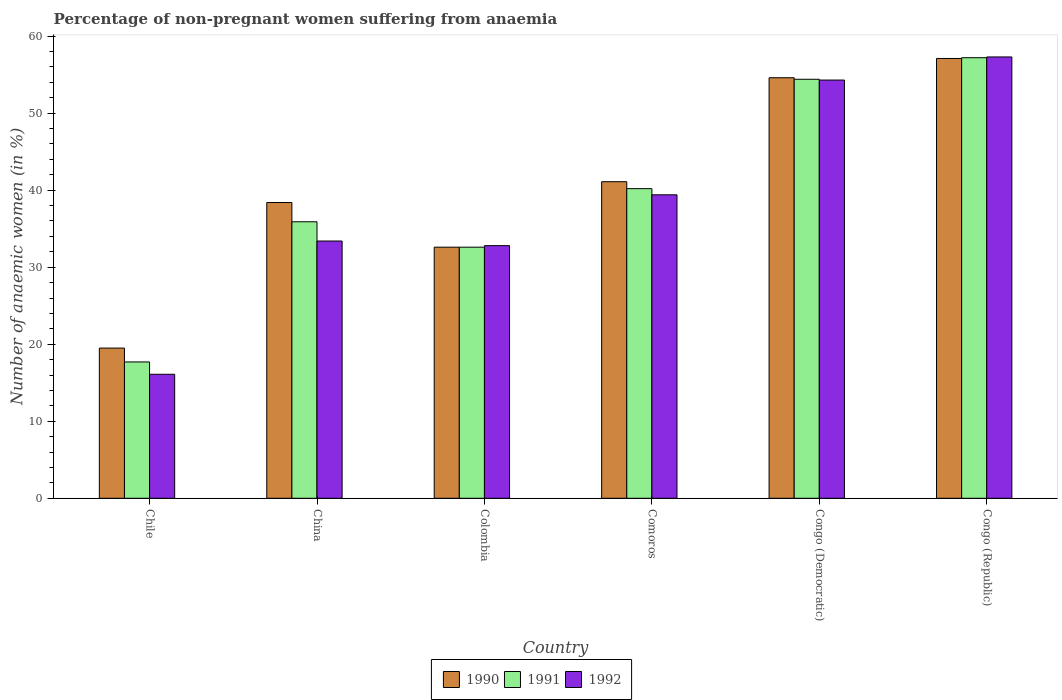How many groups of bars are there?
Offer a very short reply. 6. What is the label of the 1st group of bars from the left?
Your response must be concise. Chile. What is the percentage of non-pregnant women suffering from anaemia in 1992 in Comoros?
Make the answer very short. 39.4. Across all countries, what is the maximum percentage of non-pregnant women suffering from anaemia in 1992?
Keep it short and to the point. 57.3. Across all countries, what is the minimum percentage of non-pregnant women suffering from anaemia in 1992?
Your answer should be very brief. 16.1. In which country was the percentage of non-pregnant women suffering from anaemia in 1990 maximum?
Your answer should be very brief. Congo (Republic). What is the total percentage of non-pregnant women suffering from anaemia in 1991 in the graph?
Ensure brevity in your answer.  238. What is the difference between the percentage of non-pregnant women suffering from anaemia in 1991 in China and that in Congo (Democratic)?
Offer a terse response. -18.5. What is the difference between the percentage of non-pregnant women suffering from anaemia in 1992 in China and the percentage of non-pregnant women suffering from anaemia in 1990 in Chile?
Offer a terse response. 13.9. What is the average percentage of non-pregnant women suffering from anaemia in 1991 per country?
Your answer should be very brief. 39.67. What is the difference between the percentage of non-pregnant women suffering from anaemia of/in 1992 and percentage of non-pregnant women suffering from anaemia of/in 1990 in Comoros?
Your response must be concise. -1.7. What is the ratio of the percentage of non-pregnant women suffering from anaemia in 1990 in Colombia to that in Congo (Democratic)?
Offer a terse response. 0.6. Is the percentage of non-pregnant women suffering from anaemia in 1990 in China less than that in Colombia?
Provide a short and direct response. No. What is the difference between the highest and the lowest percentage of non-pregnant women suffering from anaemia in 1991?
Provide a short and direct response. 39.5. How many bars are there?
Provide a short and direct response. 18. What is the difference between two consecutive major ticks on the Y-axis?
Your response must be concise. 10. Does the graph contain any zero values?
Ensure brevity in your answer.  No. Where does the legend appear in the graph?
Your response must be concise. Bottom center. What is the title of the graph?
Offer a terse response. Percentage of non-pregnant women suffering from anaemia. What is the label or title of the Y-axis?
Make the answer very short. Number of anaemic women (in %). What is the Number of anaemic women (in %) in 1990 in China?
Your answer should be compact. 38.4. What is the Number of anaemic women (in %) of 1991 in China?
Your answer should be very brief. 35.9. What is the Number of anaemic women (in %) in 1992 in China?
Offer a very short reply. 33.4. What is the Number of anaemic women (in %) of 1990 in Colombia?
Offer a very short reply. 32.6. What is the Number of anaemic women (in %) of 1991 in Colombia?
Provide a short and direct response. 32.6. What is the Number of anaemic women (in %) of 1992 in Colombia?
Ensure brevity in your answer.  32.8. What is the Number of anaemic women (in %) in 1990 in Comoros?
Provide a short and direct response. 41.1. What is the Number of anaemic women (in %) in 1991 in Comoros?
Provide a short and direct response. 40.2. What is the Number of anaemic women (in %) of 1992 in Comoros?
Provide a short and direct response. 39.4. What is the Number of anaemic women (in %) of 1990 in Congo (Democratic)?
Make the answer very short. 54.6. What is the Number of anaemic women (in %) of 1991 in Congo (Democratic)?
Make the answer very short. 54.4. What is the Number of anaemic women (in %) in 1992 in Congo (Democratic)?
Your answer should be very brief. 54.3. What is the Number of anaemic women (in %) in 1990 in Congo (Republic)?
Make the answer very short. 57.1. What is the Number of anaemic women (in %) in 1991 in Congo (Republic)?
Give a very brief answer. 57.2. What is the Number of anaemic women (in %) in 1992 in Congo (Republic)?
Your answer should be very brief. 57.3. Across all countries, what is the maximum Number of anaemic women (in %) in 1990?
Your response must be concise. 57.1. Across all countries, what is the maximum Number of anaemic women (in %) in 1991?
Your answer should be compact. 57.2. Across all countries, what is the maximum Number of anaemic women (in %) of 1992?
Provide a succinct answer. 57.3. Across all countries, what is the minimum Number of anaemic women (in %) in 1990?
Provide a succinct answer. 19.5. What is the total Number of anaemic women (in %) of 1990 in the graph?
Keep it short and to the point. 243.3. What is the total Number of anaemic women (in %) in 1991 in the graph?
Keep it short and to the point. 238. What is the total Number of anaemic women (in %) in 1992 in the graph?
Your response must be concise. 233.3. What is the difference between the Number of anaemic women (in %) of 1990 in Chile and that in China?
Your answer should be compact. -18.9. What is the difference between the Number of anaemic women (in %) in 1991 in Chile and that in China?
Your response must be concise. -18.2. What is the difference between the Number of anaemic women (in %) of 1992 in Chile and that in China?
Keep it short and to the point. -17.3. What is the difference between the Number of anaemic women (in %) of 1991 in Chile and that in Colombia?
Make the answer very short. -14.9. What is the difference between the Number of anaemic women (in %) in 1992 in Chile and that in Colombia?
Give a very brief answer. -16.7. What is the difference between the Number of anaemic women (in %) in 1990 in Chile and that in Comoros?
Offer a very short reply. -21.6. What is the difference between the Number of anaemic women (in %) of 1991 in Chile and that in Comoros?
Your answer should be compact. -22.5. What is the difference between the Number of anaemic women (in %) in 1992 in Chile and that in Comoros?
Provide a short and direct response. -23.3. What is the difference between the Number of anaemic women (in %) of 1990 in Chile and that in Congo (Democratic)?
Keep it short and to the point. -35.1. What is the difference between the Number of anaemic women (in %) of 1991 in Chile and that in Congo (Democratic)?
Keep it short and to the point. -36.7. What is the difference between the Number of anaemic women (in %) in 1992 in Chile and that in Congo (Democratic)?
Make the answer very short. -38.2. What is the difference between the Number of anaemic women (in %) in 1990 in Chile and that in Congo (Republic)?
Provide a succinct answer. -37.6. What is the difference between the Number of anaemic women (in %) of 1991 in Chile and that in Congo (Republic)?
Your answer should be very brief. -39.5. What is the difference between the Number of anaemic women (in %) in 1992 in Chile and that in Congo (Republic)?
Your response must be concise. -41.2. What is the difference between the Number of anaemic women (in %) in 1991 in China and that in Colombia?
Your answer should be very brief. 3.3. What is the difference between the Number of anaemic women (in %) of 1992 in China and that in Colombia?
Ensure brevity in your answer.  0.6. What is the difference between the Number of anaemic women (in %) of 1990 in China and that in Comoros?
Your answer should be compact. -2.7. What is the difference between the Number of anaemic women (in %) of 1991 in China and that in Comoros?
Your answer should be very brief. -4.3. What is the difference between the Number of anaemic women (in %) of 1992 in China and that in Comoros?
Keep it short and to the point. -6. What is the difference between the Number of anaemic women (in %) in 1990 in China and that in Congo (Democratic)?
Give a very brief answer. -16.2. What is the difference between the Number of anaemic women (in %) in 1991 in China and that in Congo (Democratic)?
Offer a very short reply. -18.5. What is the difference between the Number of anaemic women (in %) in 1992 in China and that in Congo (Democratic)?
Provide a short and direct response. -20.9. What is the difference between the Number of anaemic women (in %) in 1990 in China and that in Congo (Republic)?
Offer a terse response. -18.7. What is the difference between the Number of anaemic women (in %) of 1991 in China and that in Congo (Republic)?
Your answer should be very brief. -21.3. What is the difference between the Number of anaemic women (in %) in 1992 in China and that in Congo (Republic)?
Offer a terse response. -23.9. What is the difference between the Number of anaemic women (in %) in 1991 in Colombia and that in Comoros?
Your response must be concise. -7.6. What is the difference between the Number of anaemic women (in %) in 1992 in Colombia and that in Comoros?
Offer a very short reply. -6.6. What is the difference between the Number of anaemic women (in %) in 1991 in Colombia and that in Congo (Democratic)?
Keep it short and to the point. -21.8. What is the difference between the Number of anaemic women (in %) in 1992 in Colombia and that in Congo (Democratic)?
Your answer should be very brief. -21.5. What is the difference between the Number of anaemic women (in %) in 1990 in Colombia and that in Congo (Republic)?
Give a very brief answer. -24.5. What is the difference between the Number of anaemic women (in %) of 1991 in Colombia and that in Congo (Republic)?
Give a very brief answer. -24.6. What is the difference between the Number of anaemic women (in %) in 1992 in Colombia and that in Congo (Republic)?
Provide a succinct answer. -24.5. What is the difference between the Number of anaemic women (in %) of 1992 in Comoros and that in Congo (Democratic)?
Provide a short and direct response. -14.9. What is the difference between the Number of anaemic women (in %) in 1990 in Comoros and that in Congo (Republic)?
Offer a very short reply. -16. What is the difference between the Number of anaemic women (in %) in 1992 in Comoros and that in Congo (Republic)?
Your answer should be compact. -17.9. What is the difference between the Number of anaemic women (in %) of 1991 in Congo (Democratic) and that in Congo (Republic)?
Keep it short and to the point. -2.8. What is the difference between the Number of anaemic women (in %) of 1990 in Chile and the Number of anaemic women (in %) of 1991 in China?
Make the answer very short. -16.4. What is the difference between the Number of anaemic women (in %) of 1990 in Chile and the Number of anaemic women (in %) of 1992 in China?
Your answer should be very brief. -13.9. What is the difference between the Number of anaemic women (in %) of 1991 in Chile and the Number of anaemic women (in %) of 1992 in China?
Offer a very short reply. -15.7. What is the difference between the Number of anaemic women (in %) of 1990 in Chile and the Number of anaemic women (in %) of 1991 in Colombia?
Give a very brief answer. -13.1. What is the difference between the Number of anaemic women (in %) in 1990 in Chile and the Number of anaemic women (in %) in 1992 in Colombia?
Make the answer very short. -13.3. What is the difference between the Number of anaemic women (in %) of 1991 in Chile and the Number of anaemic women (in %) of 1992 in Colombia?
Provide a short and direct response. -15.1. What is the difference between the Number of anaemic women (in %) of 1990 in Chile and the Number of anaemic women (in %) of 1991 in Comoros?
Provide a short and direct response. -20.7. What is the difference between the Number of anaemic women (in %) of 1990 in Chile and the Number of anaemic women (in %) of 1992 in Comoros?
Offer a terse response. -19.9. What is the difference between the Number of anaemic women (in %) in 1991 in Chile and the Number of anaemic women (in %) in 1992 in Comoros?
Your answer should be compact. -21.7. What is the difference between the Number of anaemic women (in %) in 1990 in Chile and the Number of anaemic women (in %) in 1991 in Congo (Democratic)?
Provide a short and direct response. -34.9. What is the difference between the Number of anaemic women (in %) of 1990 in Chile and the Number of anaemic women (in %) of 1992 in Congo (Democratic)?
Your answer should be compact. -34.8. What is the difference between the Number of anaemic women (in %) in 1991 in Chile and the Number of anaemic women (in %) in 1992 in Congo (Democratic)?
Keep it short and to the point. -36.6. What is the difference between the Number of anaemic women (in %) of 1990 in Chile and the Number of anaemic women (in %) of 1991 in Congo (Republic)?
Make the answer very short. -37.7. What is the difference between the Number of anaemic women (in %) in 1990 in Chile and the Number of anaemic women (in %) in 1992 in Congo (Republic)?
Keep it short and to the point. -37.8. What is the difference between the Number of anaemic women (in %) of 1991 in Chile and the Number of anaemic women (in %) of 1992 in Congo (Republic)?
Provide a short and direct response. -39.6. What is the difference between the Number of anaemic women (in %) of 1990 in China and the Number of anaemic women (in %) of 1992 in Colombia?
Provide a short and direct response. 5.6. What is the difference between the Number of anaemic women (in %) in 1991 in China and the Number of anaemic women (in %) in 1992 in Colombia?
Provide a short and direct response. 3.1. What is the difference between the Number of anaemic women (in %) in 1990 in China and the Number of anaemic women (in %) in 1991 in Comoros?
Your answer should be compact. -1.8. What is the difference between the Number of anaemic women (in %) in 1990 in China and the Number of anaemic women (in %) in 1992 in Comoros?
Give a very brief answer. -1. What is the difference between the Number of anaemic women (in %) of 1990 in China and the Number of anaemic women (in %) of 1992 in Congo (Democratic)?
Ensure brevity in your answer.  -15.9. What is the difference between the Number of anaemic women (in %) in 1991 in China and the Number of anaemic women (in %) in 1992 in Congo (Democratic)?
Your response must be concise. -18.4. What is the difference between the Number of anaemic women (in %) in 1990 in China and the Number of anaemic women (in %) in 1991 in Congo (Republic)?
Your answer should be compact. -18.8. What is the difference between the Number of anaemic women (in %) in 1990 in China and the Number of anaemic women (in %) in 1992 in Congo (Republic)?
Provide a short and direct response. -18.9. What is the difference between the Number of anaemic women (in %) in 1991 in China and the Number of anaemic women (in %) in 1992 in Congo (Republic)?
Offer a very short reply. -21.4. What is the difference between the Number of anaemic women (in %) in 1990 in Colombia and the Number of anaemic women (in %) in 1992 in Comoros?
Keep it short and to the point. -6.8. What is the difference between the Number of anaemic women (in %) of 1990 in Colombia and the Number of anaemic women (in %) of 1991 in Congo (Democratic)?
Offer a terse response. -21.8. What is the difference between the Number of anaemic women (in %) in 1990 in Colombia and the Number of anaemic women (in %) in 1992 in Congo (Democratic)?
Ensure brevity in your answer.  -21.7. What is the difference between the Number of anaemic women (in %) in 1991 in Colombia and the Number of anaemic women (in %) in 1992 in Congo (Democratic)?
Offer a terse response. -21.7. What is the difference between the Number of anaemic women (in %) of 1990 in Colombia and the Number of anaemic women (in %) of 1991 in Congo (Republic)?
Your answer should be very brief. -24.6. What is the difference between the Number of anaemic women (in %) in 1990 in Colombia and the Number of anaemic women (in %) in 1992 in Congo (Republic)?
Make the answer very short. -24.7. What is the difference between the Number of anaemic women (in %) in 1991 in Colombia and the Number of anaemic women (in %) in 1992 in Congo (Republic)?
Your answer should be compact. -24.7. What is the difference between the Number of anaemic women (in %) of 1990 in Comoros and the Number of anaemic women (in %) of 1992 in Congo (Democratic)?
Ensure brevity in your answer.  -13.2. What is the difference between the Number of anaemic women (in %) in 1991 in Comoros and the Number of anaemic women (in %) in 1992 in Congo (Democratic)?
Make the answer very short. -14.1. What is the difference between the Number of anaemic women (in %) in 1990 in Comoros and the Number of anaemic women (in %) in 1991 in Congo (Republic)?
Ensure brevity in your answer.  -16.1. What is the difference between the Number of anaemic women (in %) of 1990 in Comoros and the Number of anaemic women (in %) of 1992 in Congo (Republic)?
Your answer should be compact. -16.2. What is the difference between the Number of anaemic women (in %) in 1991 in Comoros and the Number of anaemic women (in %) in 1992 in Congo (Republic)?
Keep it short and to the point. -17.1. What is the difference between the Number of anaemic women (in %) in 1990 in Congo (Democratic) and the Number of anaemic women (in %) in 1991 in Congo (Republic)?
Offer a very short reply. -2.6. What is the average Number of anaemic women (in %) of 1990 per country?
Provide a succinct answer. 40.55. What is the average Number of anaemic women (in %) in 1991 per country?
Make the answer very short. 39.67. What is the average Number of anaemic women (in %) of 1992 per country?
Your answer should be compact. 38.88. What is the difference between the Number of anaemic women (in %) in 1990 and Number of anaemic women (in %) in 1991 in China?
Offer a terse response. 2.5. What is the difference between the Number of anaemic women (in %) in 1990 and Number of anaemic women (in %) in 1992 in China?
Your answer should be compact. 5. What is the difference between the Number of anaemic women (in %) of 1990 and Number of anaemic women (in %) of 1992 in Colombia?
Your response must be concise. -0.2. What is the difference between the Number of anaemic women (in %) in 1991 and Number of anaemic women (in %) in 1992 in Colombia?
Keep it short and to the point. -0.2. What is the difference between the Number of anaemic women (in %) in 1990 and Number of anaemic women (in %) in 1992 in Comoros?
Provide a short and direct response. 1.7. What is the difference between the Number of anaemic women (in %) in 1991 and Number of anaemic women (in %) in 1992 in Comoros?
Your response must be concise. 0.8. What is the difference between the Number of anaemic women (in %) in 1990 and Number of anaemic women (in %) in 1992 in Congo (Democratic)?
Give a very brief answer. 0.3. What is the difference between the Number of anaemic women (in %) of 1991 and Number of anaemic women (in %) of 1992 in Congo (Democratic)?
Make the answer very short. 0.1. What is the ratio of the Number of anaemic women (in %) of 1990 in Chile to that in China?
Provide a short and direct response. 0.51. What is the ratio of the Number of anaemic women (in %) of 1991 in Chile to that in China?
Keep it short and to the point. 0.49. What is the ratio of the Number of anaemic women (in %) of 1992 in Chile to that in China?
Your answer should be very brief. 0.48. What is the ratio of the Number of anaemic women (in %) in 1990 in Chile to that in Colombia?
Your answer should be very brief. 0.6. What is the ratio of the Number of anaemic women (in %) in 1991 in Chile to that in Colombia?
Provide a short and direct response. 0.54. What is the ratio of the Number of anaemic women (in %) in 1992 in Chile to that in Colombia?
Provide a succinct answer. 0.49. What is the ratio of the Number of anaemic women (in %) in 1990 in Chile to that in Comoros?
Offer a very short reply. 0.47. What is the ratio of the Number of anaemic women (in %) in 1991 in Chile to that in Comoros?
Offer a terse response. 0.44. What is the ratio of the Number of anaemic women (in %) in 1992 in Chile to that in Comoros?
Provide a succinct answer. 0.41. What is the ratio of the Number of anaemic women (in %) of 1990 in Chile to that in Congo (Democratic)?
Your response must be concise. 0.36. What is the ratio of the Number of anaemic women (in %) in 1991 in Chile to that in Congo (Democratic)?
Provide a short and direct response. 0.33. What is the ratio of the Number of anaemic women (in %) of 1992 in Chile to that in Congo (Democratic)?
Your answer should be compact. 0.3. What is the ratio of the Number of anaemic women (in %) of 1990 in Chile to that in Congo (Republic)?
Provide a short and direct response. 0.34. What is the ratio of the Number of anaemic women (in %) in 1991 in Chile to that in Congo (Republic)?
Provide a short and direct response. 0.31. What is the ratio of the Number of anaemic women (in %) in 1992 in Chile to that in Congo (Republic)?
Your answer should be compact. 0.28. What is the ratio of the Number of anaemic women (in %) in 1990 in China to that in Colombia?
Ensure brevity in your answer.  1.18. What is the ratio of the Number of anaemic women (in %) of 1991 in China to that in Colombia?
Ensure brevity in your answer.  1.1. What is the ratio of the Number of anaemic women (in %) in 1992 in China to that in Colombia?
Offer a terse response. 1.02. What is the ratio of the Number of anaemic women (in %) in 1990 in China to that in Comoros?
Offer a very short reply. 0.93. What is the ratio of the Number of anaemic women (in %) in 1991 in China to that in Comoros?
Offer a terse response. 0.89. What is the ratio of the Number of anaemic women (in %) in 1992 in China to that in Comoros?
Offer a terse response. 0.85. What is the ratio of the Number of anaemic women (in %) in 1990 in China to that in Congo (Democratic)?
Provide a short and direct response. 0.7. What is the ratio of the Number of anaemic women (in %) in 1991 in China to that in Congo (Democratic)?
Offer a terse response. 0.66. What is the ratio of the Number of anaemic women (in %) of 1992 in China to that in Congo (Democratic)?
Your answer should be compact. 0.62. What is the ratio of the Number of anaemic women (in %) in 1990 in China to that in Congo (Republic)?
Ensure brevity in your answer.  0.67. What is the ratio of the Number of anaemic women (in %) in 1991 in China to that in Congo (Republic)?
Ensure brevity in your answer.  0.63. What is the ratio of the Number of anaemic women (in %) of 1992 in China to that in Congo (Republic)?
Give a very brief answer. 0.58. What is the ratio of the Number of anaemic women (in %) of 1990 in Colombia to that in Comoros?
Provide a succinct answer. 0.79. What is the ratio of the Number of anaemic women (in %) of 1991 in Colombia to that in Comoros?
Ensure brevity in your answer.  0.81. What is the ratio of the Number of anaemic women (in %) of 1992 in Colombia to that in Comoros?
Your response must be concise. 0.83. What is the ratio of the Number of anaemic women (in %) of 1990 in Colombia to that in Congo (Democratic)?
Provide a succinct answer. 0.6. What is the ratio of the Number of anaemic women (in %) in 1991 in Colombia to that in Congo (Democratic)?
Offer a terse response. 0.6. What is the ratio of the Number of anaemic women (in %) of 1992 in Colombia to that in Congo (Democratic)?
Keep it short and to the point. 0.6. What is the ratio of the Number of anaemic women (in %) of 1990 in Colombia to that in Congo (Republic)?
Provide a short and direct response. 0.57. What is the ratio of the Number of anaemic women (in %) of 1991 in Colombia to that in Congo (Republic)?
Ensure brevity in your answer.  0.57. What is the ratio of the Number of anaemic women (in %) of 1992 in Colombia to that in Congo (Republic)?
Make the answer very short. 0.57. What is the ratio of the Number of anaemic women (in %) in 1990 in Comoros to that in Congo (Democratic)?
Give a very brief answer. 0.75. What is the ratio of the Number of anaemic women (in %) in 1991 in Comoros to that in Congo (Democratic)?
Offer a very short reply. 0.74. What is the ratio of the Number of anaemic women (in %) in 1992 in Comoros to that in Congo (Democratic)?
Your answer should be very brief. 0.73. What is the ratio of the Number of anaemic women (in %) in 1990 in Comoros to that in Congo (Republic)?
Provide a succinct answer. 0.72. What is the ratio of the Number of anaemic women (in %) in 1991 in Comoros to that in Congo (Republic)?
Offer a very short reply. 0.7. What is the ratio of the Number of anaemic women (in %) of 1992 in Comoros to that in Congo (Republic)?
Provide a short and direct response. 0.69. What is the ratio of the Number of anaemic women (in %) of 1990 in Congo (Democratic) to that in Congo (Republic)?
Provide a succinct answer. 0.96. What is the ratio of the Number of anaemic women (in %) of 1991 in Congo (Democratic) to that in Congo (Republic)?
Offer a very short reply. 0.95. What is the ratio of the Number of anaemic women (in %) of 1992 in Congo (Democratic) to that in Congo (Republic)?
Provide a short and direct response. 0.95. What is the difference between the highest and the second highest Number of anaemic women (in %) of 1991?
Provide a succinct answer. 2.8. What is the difference between the highest and the second highest Number of anaemic women (in %) of 1992?
Offer a terse response. 3. What is the difference between the highest and the lowest Number of anaemic women (in %) of 1990?
Ensure brevity in your answer.  37.6. What is the difference between the highest and the lowest Number of anaemic women (in %) in 1991?
Offer a terse response. 39.5. What is the difference between the highest and the lowest Number of anaemic women (in %) of 1992?
Your response must be concise. 41.2. 